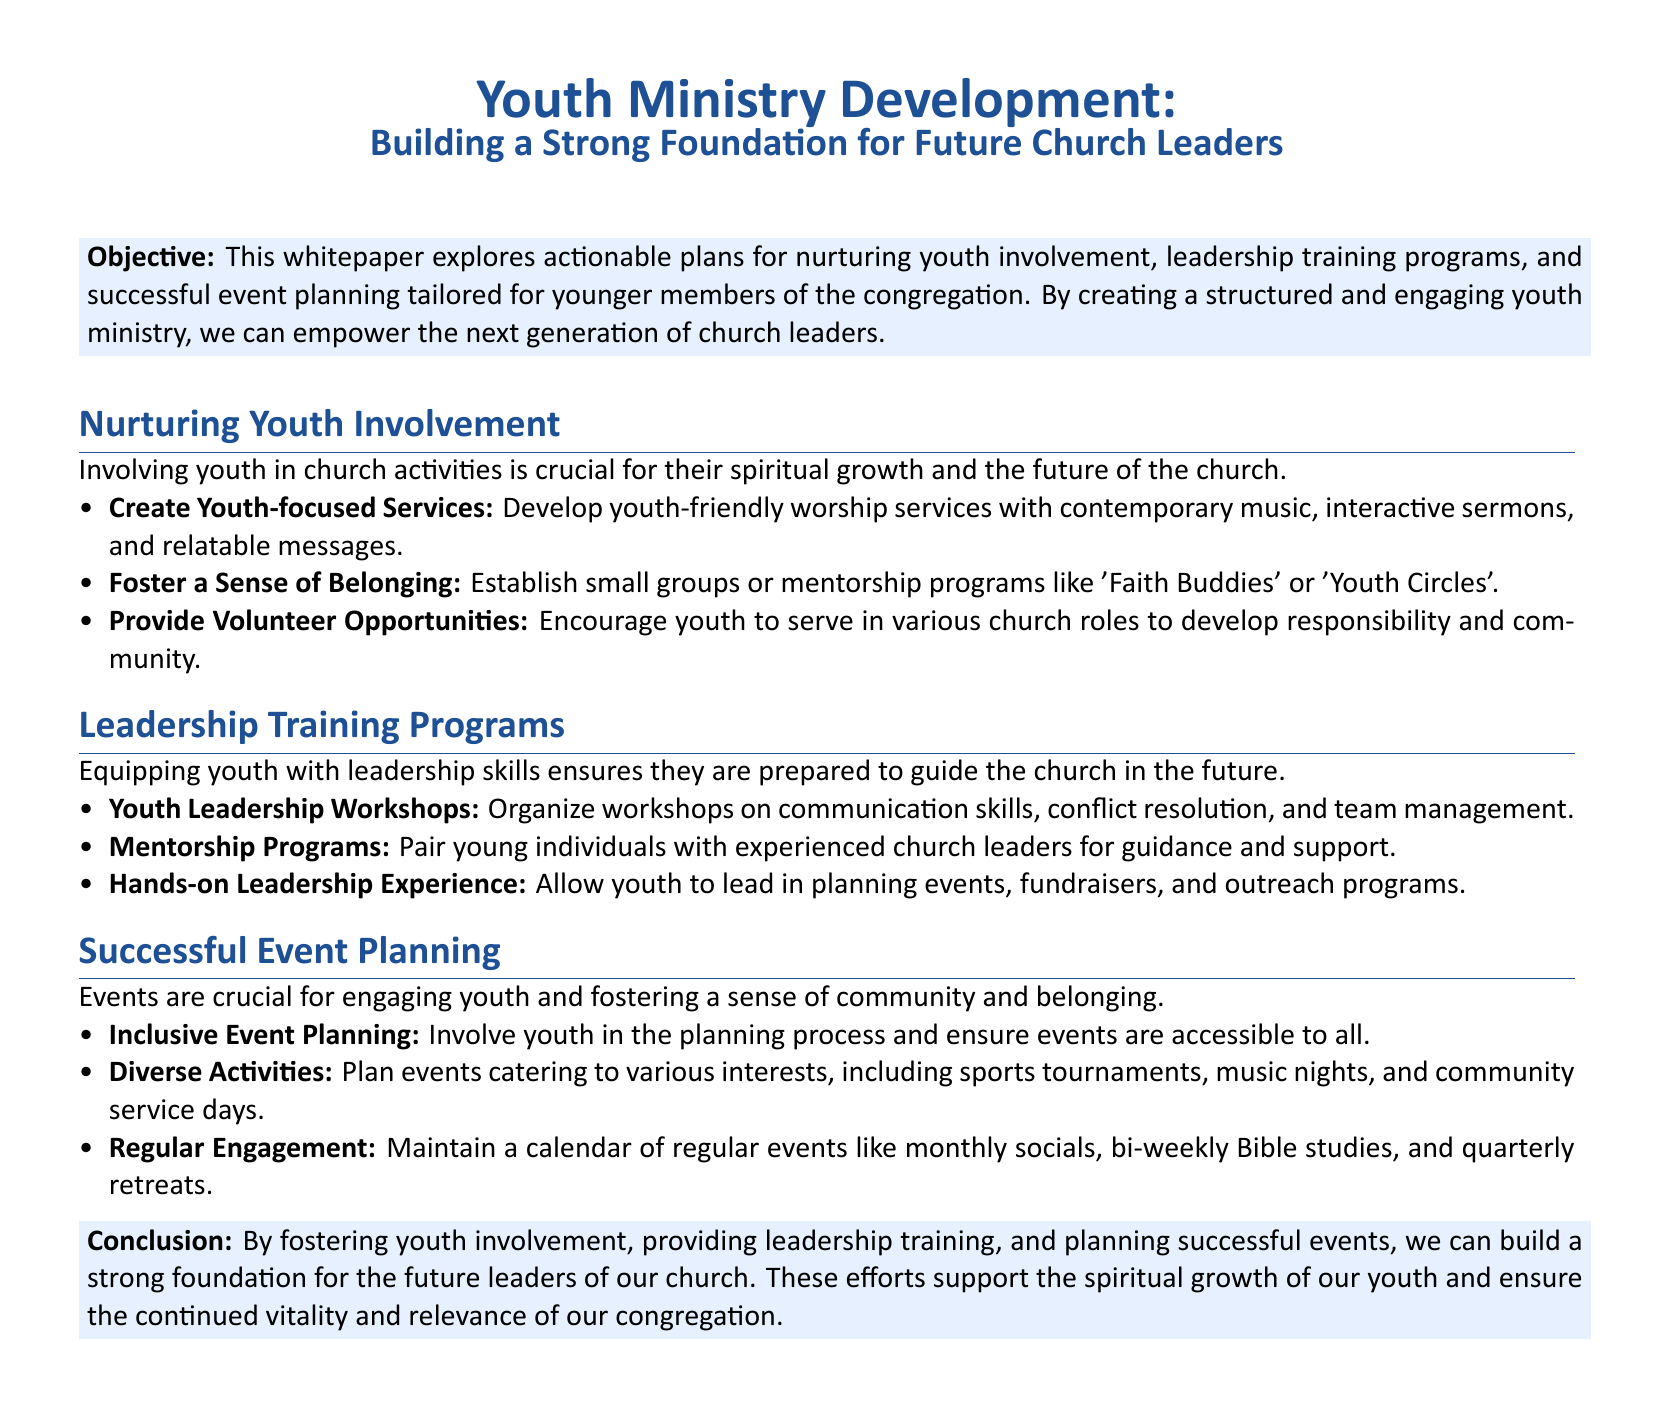What is the objective of the whitepaper? The objective is to explore actionable plans for nurturing youth involvement, leadership training programs, and successful event planning tailored for younger members of the congregation.
Answer: Explore actionable plans for nurturing youth involvement What program is suggested to foster a sense of belonging among youth? The document mentions establishing small groups or mentorship programs like 'Faith Buddies' or 'Youth Circles'.
Answer: 'Faith Buddies' or 'Youth Circles' How many workshop areas are mentioned under Leadership Training Programs? The document lists three areas: communication skills, conflict resolution, and team management.
Answer: Three What type of events should be planned to cater to various interests? The document states that events should include sports tournaments, music nights, and community service days.
Answer: Sports tournaments, music nights, and community service days What is a key conclusion of the whitepaper? The conclusion emphasizes that fostering youth involvement, providing leadership training, and planning successful events will build a strong foundation for future leaders.
Answer: Build a strong foundation for future leaders 